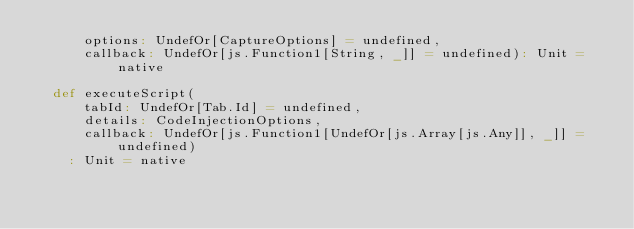Convert code to text. <code><loc_0><loc_0><loc_500><loc_500><_Scala_>      options: UndefOr[CaptureOptions] = undefined,
      callback: UndefOr[js.Function1[String, _]] = undefined): Unit = native

  def executeScript(
      tabId: UndefOr[Tab.Id] = undefined,
      details: CodeInjectionOptions,
      callback: UndefOr[js.Function1[UndefOr[js.Array[js.Any]], _]] = undefined)
    : Unit = native
</code> 